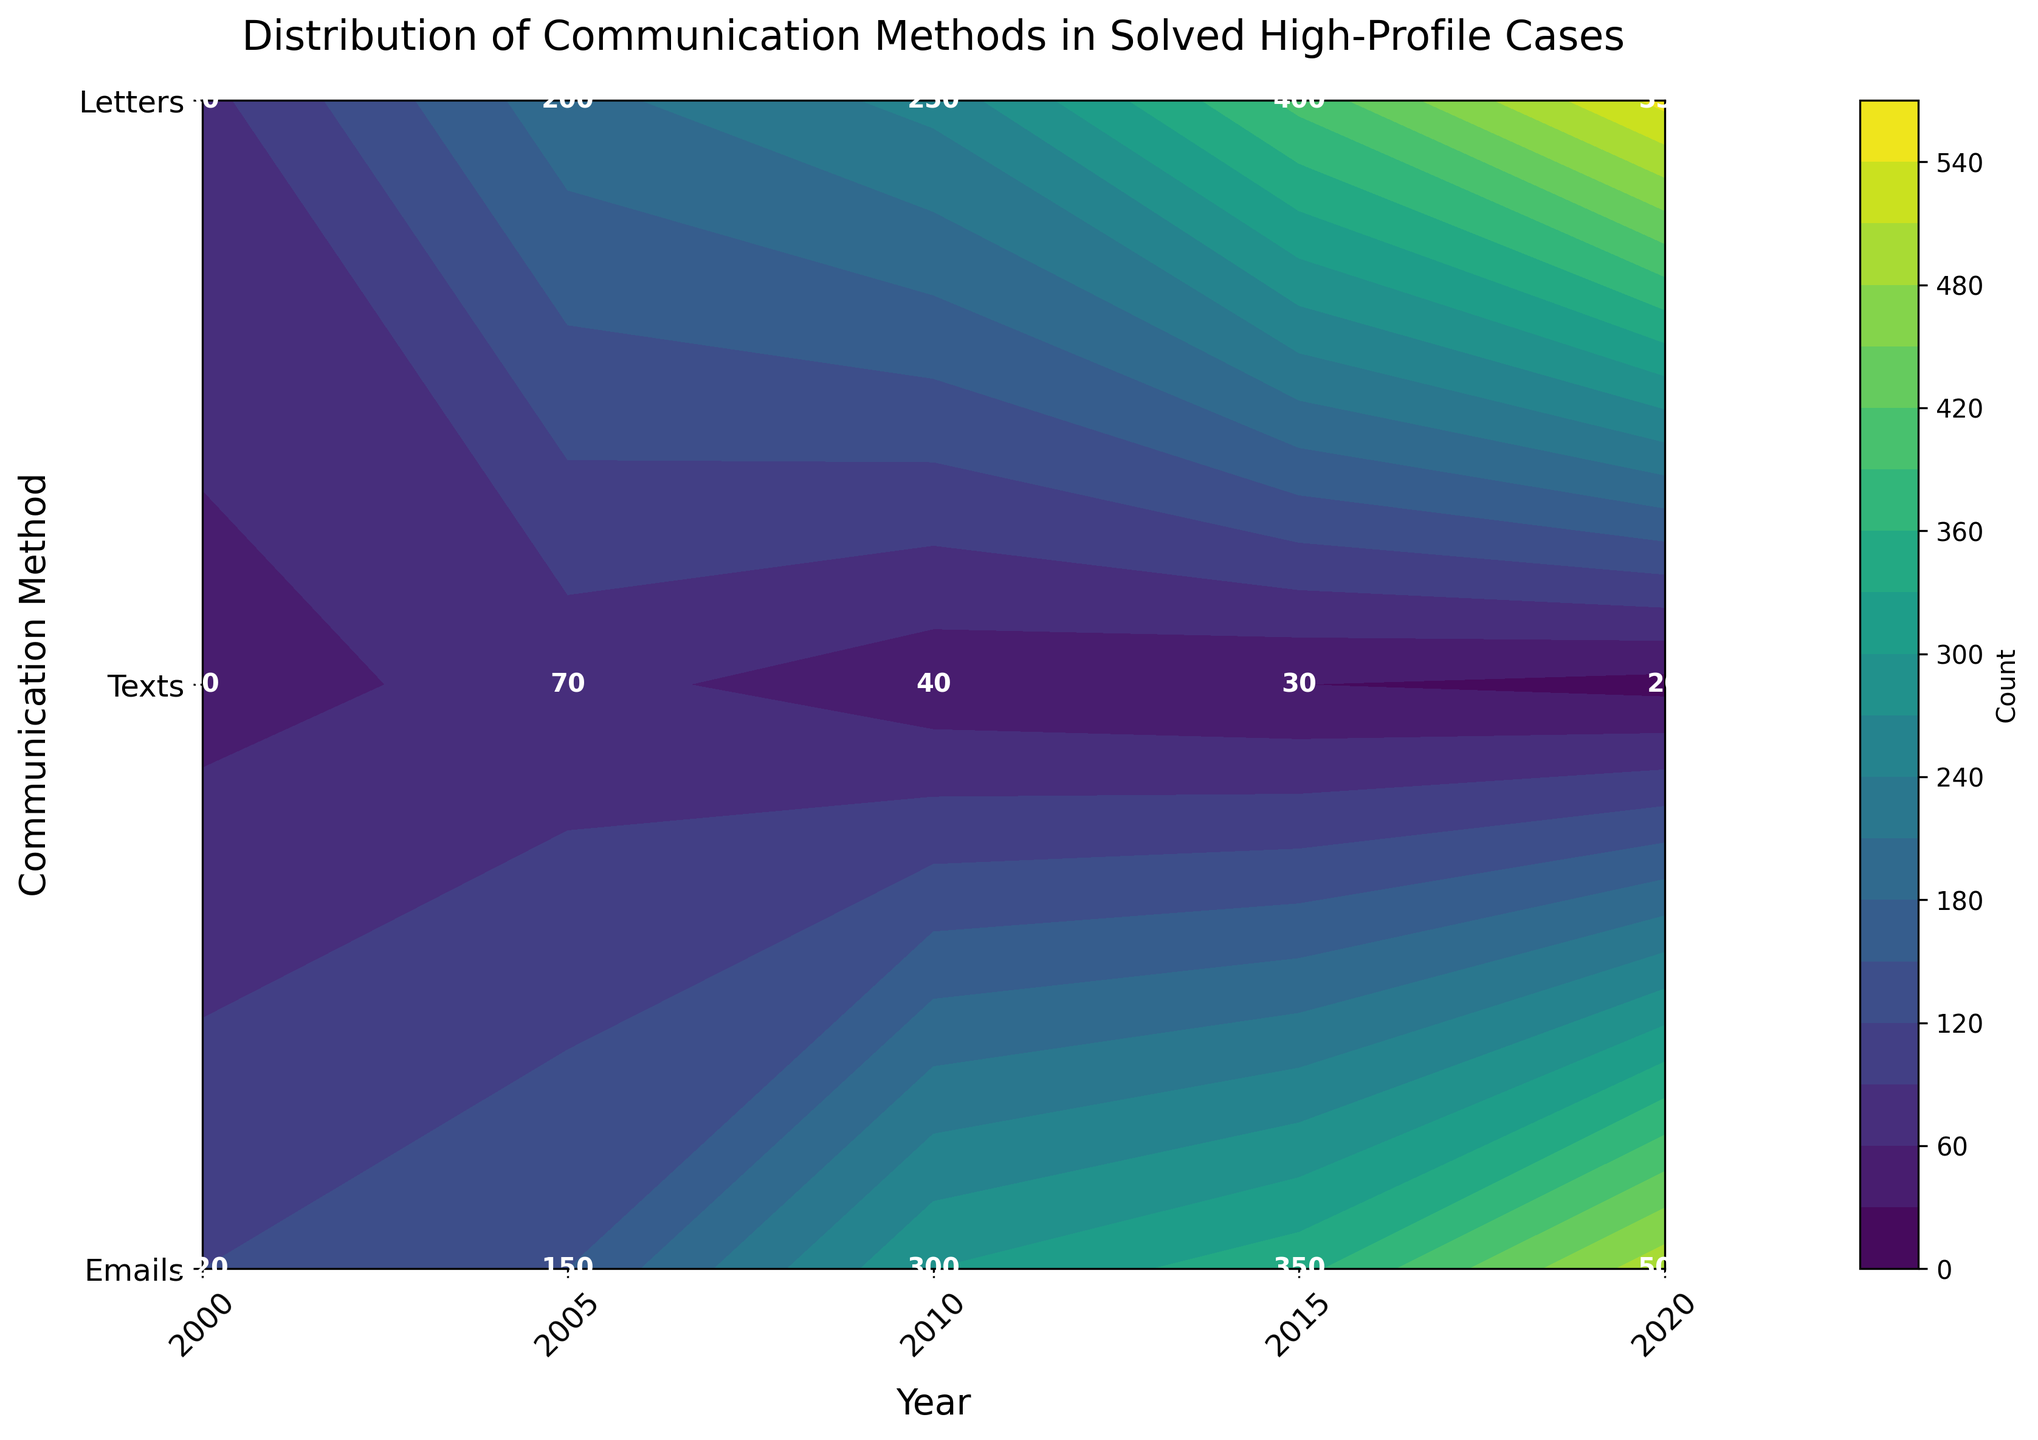What does the title of the graph say? The title is located at the top of the graph and summarizes its content. It reads "Distribution of Communication Methods in Solved High-Profile Cases."
Answer: Distribution of Communication Methods in Solved High-Profile Cases Which communication method had the highest count in the year 2020? To determine the highest count in 2020, locate the year on the x-axis and compare values for different methods on the y-axis. Emails had the highest count of 500.
Answer: Emails How did the usage of letters change from 2000 to 2020? Look at the contour colors and the numbers at the y-axis 'Letters' row for 2000 (50) and gradually compare each year until 2020 (20). The usage declined.
Answer: Declined What was the count difference between texts and emails in 2015? Find the numbers for texts and emails in 2015 on the graph: texts (400) and emails (350). Subtract the smaller number from the larger: 400 - 350.
Answer: 50 What trend do you observe in the usage of emails over the years? Look at the values for emails from 2000 to 2020. The counts are increasing: 120, 150, 300, 350, 500.
Answer: Increasing In which year did texts surpass emails in count for the first time? Compare the counts of texts and emails at each year until texts count is higher. Texts first surpass emails in 2005 (texts 200, emails 150).
Answer: 2005 What is the count of letters in 2010? Locate the year 2010 on the x-axis and check the value on the y-axis for letters. It shows 40.
Answer: 40 Between 2005 and 2010, by how much did the count of texts increase? Locate 2005 and 2010 data points for texts. Subtract the 2005 value (200) from the 2010 value (250).
Answer: 50 Which communication method had the least count in 2015? Compare counts for each method in 2015. Letters had the least count (30).
Answer: Letters How many more texts were used than letters in 2005? Locate the 2005 counts for texts (200) and letters (70), then subtract letters' count from texts' count: 200 - 70.
Answer: 130 